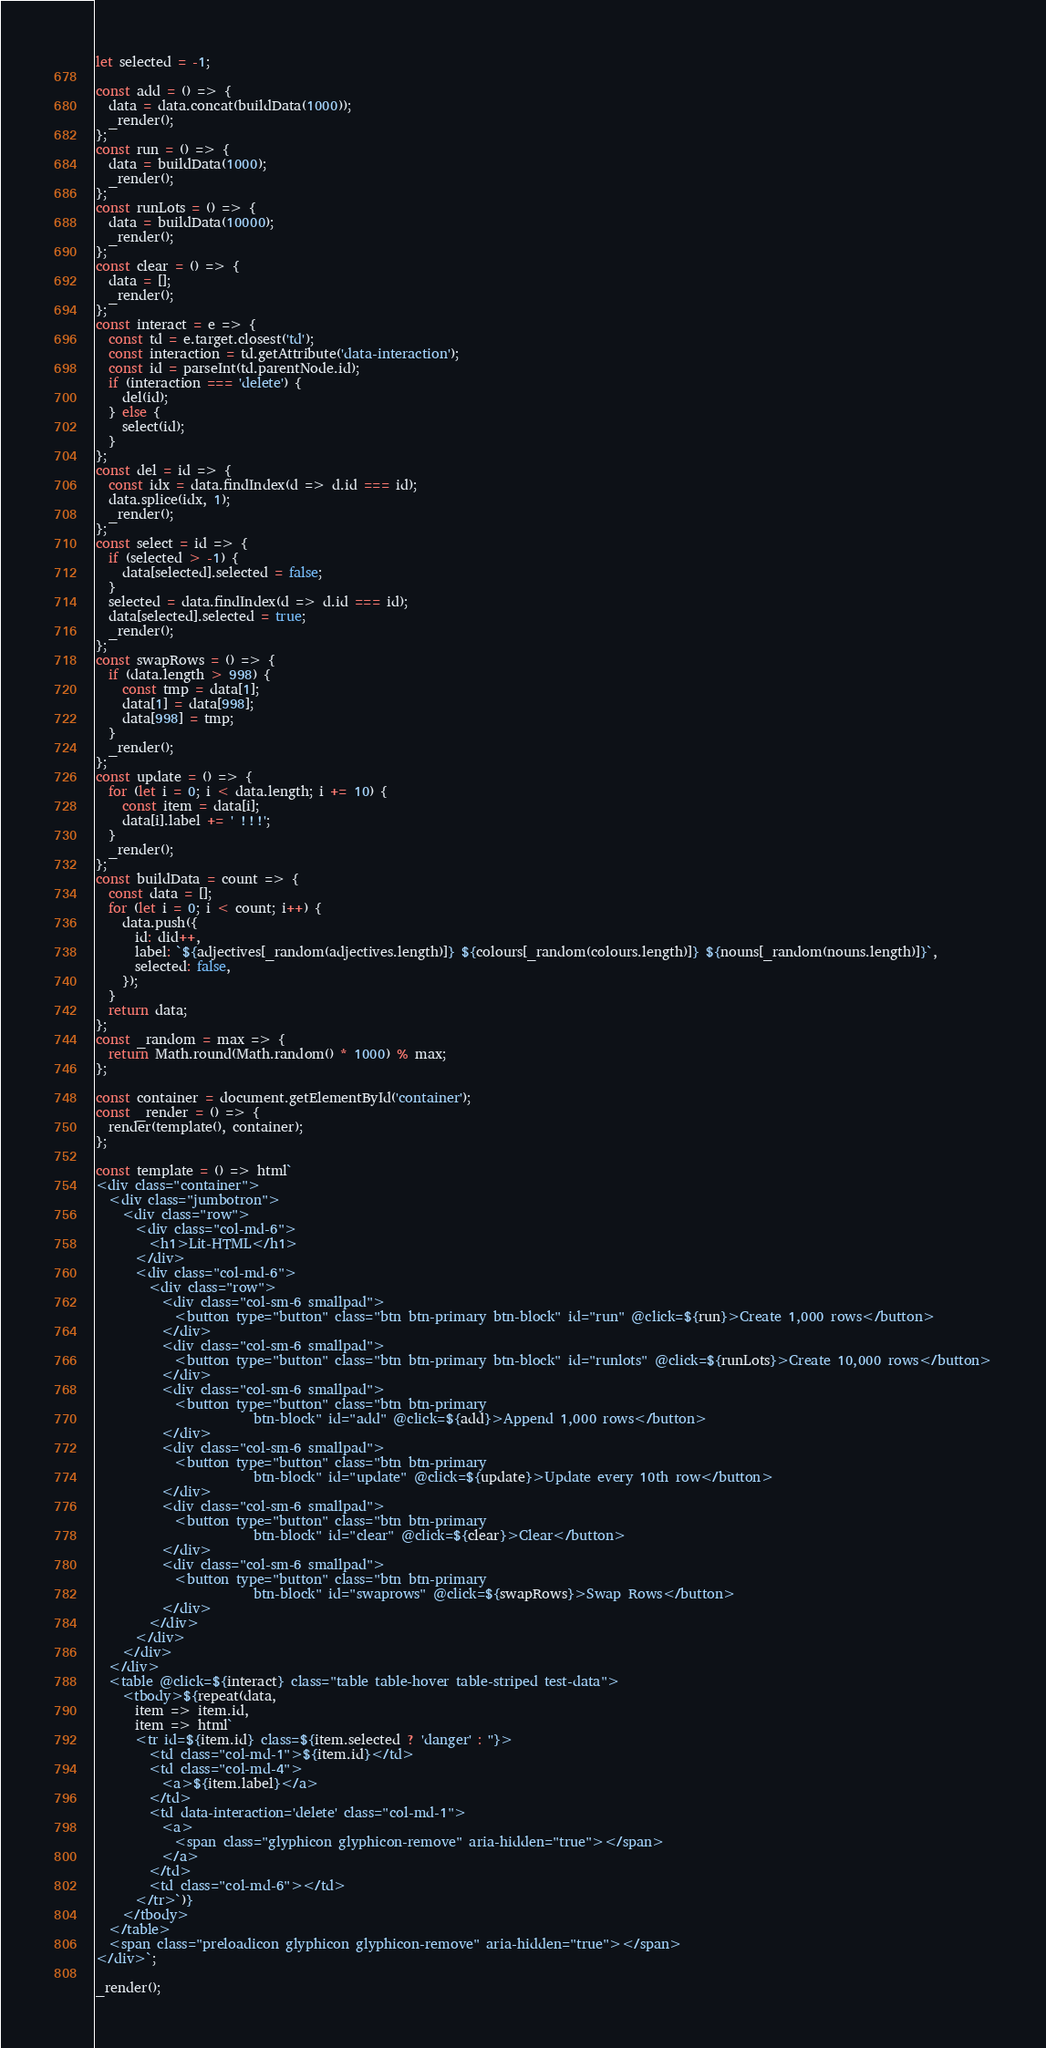Convert code to text. <code><loc_0><loc_0><loc_500><loc_500><_JavaScript_>let selected = -1;

const add = () => {
  data = data.concat(buildData(1000));
  _render();
};
const run = () => {
  data = buildData(1000);
  _render();
};
const runLots = () => {
  data = buildData(10000);
  _render();
};
const clear = () => {
  data = [];
  _render();
};
const interact = e => {
  const td = e.target.closest('td');
  const interaction = td.getAttribute('data-interaction');
  const id = parseInt(td.parentNode.id);
  if (interaction === 'delete') {
    del(id);
  } else {
    select(id);
  }
};
const del = id => {
  const idx = data.findIndex(d => d.id === id);
  data.splice(idx, 1);
  _render();
};
const select = id => {
  if (selected > -1) {
    data[selected].selected = false;
  }
  selected = data.findIndex(d => d.id === id);
  data[selected].selected = true;
  _render();
};
const swapRows = () => {
  if (data.length > 998) {
    const tmp = data[1];
    data[1] = data[998];
    data[998] = tmp;
  }
  _render();
};
const update = () => {
  for (let i = 0; i < data.length; i += 10) {
    const item = data[i];
    data[i].label += ' !!!';
  }
  _render();
};
const buildData = count => {
  const data = [];
  for (let i = 0; i < count; i++) {
    data.push({
      id: did++,
      label: `${adjectives[_random(adjectives.length)]} ${colours[_random(colours.length)]} ${nouns[_random(nouns.length)]}`,
      selected: false,
    });
  }
  return data;
};
const _random = max => {
  return Math.round(Math.random() * 1000) % max;
};

const container = document.getElementById('container');
const _render = () => {
  render(template(), container);
};

const template = () => html`
<div class="container">
  <div class="jumbotron">
    <div class="row">
      <div class="col-md-6">
        <h1>Lit-HTML</h1>
      </div>
      <div class="col-md-6">
        <div class="row">
          <div class="col-sm-6 smallpad">
            <button type="button" class="btn btn-primary btn-block" id="run" @click=${run}>Create 1,000 rows</button>
          </div>
          <div class="col-sm-6 smallpad">
            <button type="button" class="btn btn-primary btn-block" id="runlots" @click=${runLots}>Create 10,000 rows</button>
          </div>
          <div class="col-sm-6 smallpad">
            <button type="button" class="btn btn-primary
                        btn-block" id="add" @click=${add}>Append 1,000 rows</button>
          </div>
          <div class="col-sm-6 smallpad">
            <button type="button" class="btn btn-primary
                        btn-block" id="update" @click=${update}>Update every 10th row</button>
          </div>
          <div class="col-sm-6 smallpad">
            <button type="button" class="btn btn-primary
                        btn-block" id="clear" @click=${clear}>Clear</button>
          </div>
          <div class="col-sm-6 smallpad">
            <button type="button" class="btn btn-primary
                        btn-block" id="swaprows" @click=${swapRows}>Swap Rows</button>
          </div>
        </div>
      </div>
    </div>
  </div>
  <table @click=${interact} class="table table-hover table-striped test-data">
    <tbody>${repeat(data,
      item => item.id,
      item => html`
      <tr id=${item.id} class=${item.selected ? 'danger' : ''}>
        <td class="col-md-1">${item.id}</td>
        <td class="col-md-4">
          <a>${item.label}</a>
        </td>
        <td data-interaction='delete' class="col-md-1">
          <a>
            <span class="glyphicon glyphicon-remove" aria-hidden="true"></span>
          </a>
        </td>
        <td class="col-md-6"></td>
      </tr>`)}
    </tbody>
  </table>
  <span class="preloadicon glyphicon glyphicon-remove" aria-hidden="true"></span>
</div>`;

_render();
</code> 